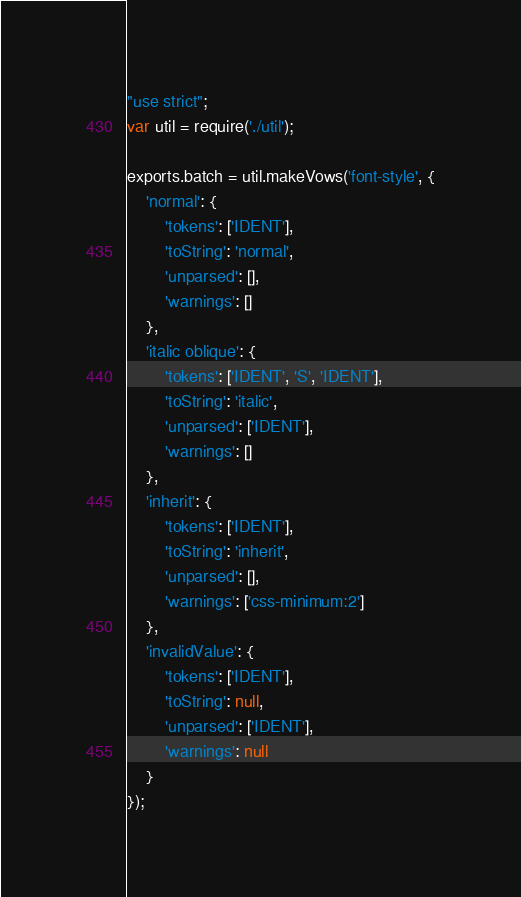Convert code to text. <code><loc_0><loc_0><loc_500><loc_500><_JavaScript_>"use strict";
var util = require('./util');

exports.batch = util.makeVows('font-style', {
	'normal': {
		'tokens': ['IDENT'],
		'toString': 'normal',
		'unparsed': [],
		'warnings': []
	},
	'italic oblique': {
		'tokens': ['IDENT', 'S', 'IDENT'],
		'toString': 'italic',
		'unparsed': ['IDENT'],
		'warnings': []
	},
	'inherit': {
		'tokens': ['IDENT'],
		'toString': 'inherit',
		'unparsed': [],
		'warnings': ['css-minimum:2']
	},
	'invalidValue': {
		'tokens': ['IDENT'],
		'toString': null,
		'unparsed': ['IDENT'],
		'warnings': null
	}
});
</code> 